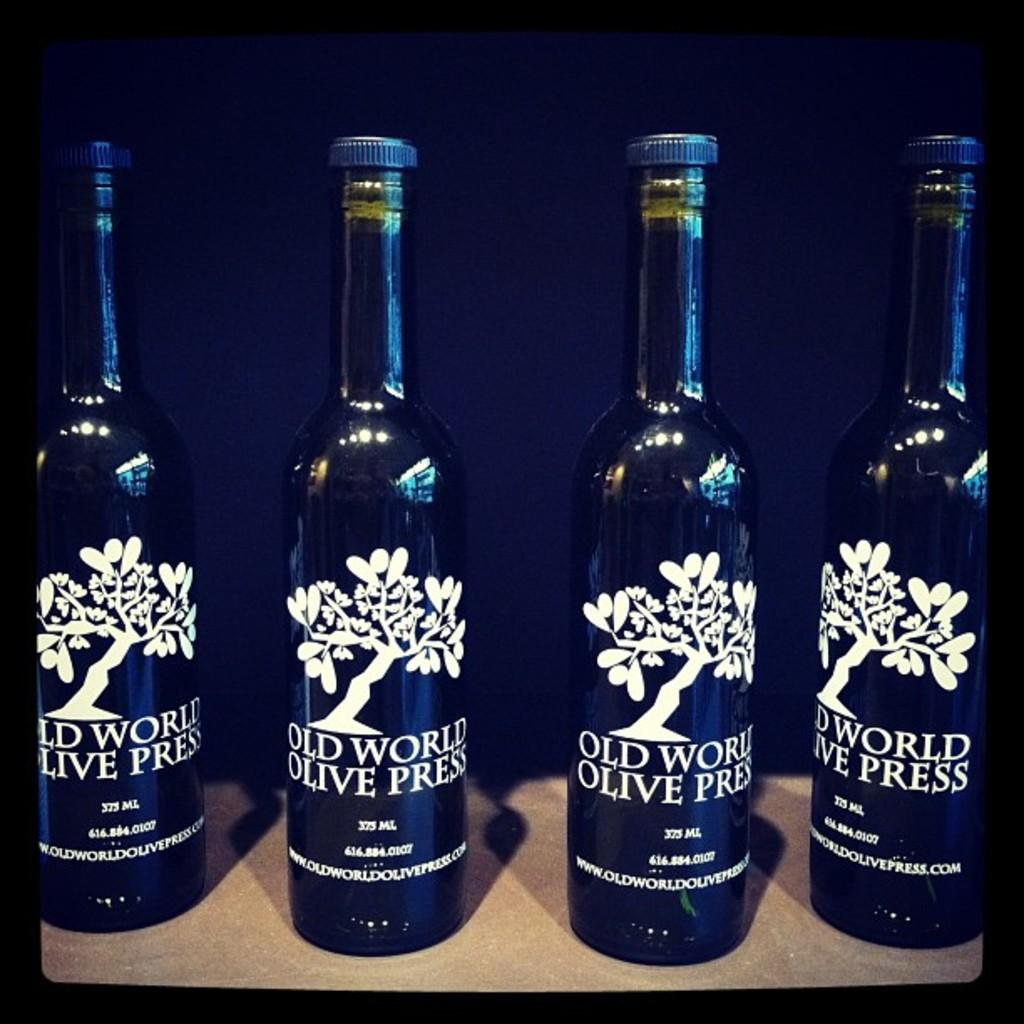<image>
Render a clear and concise summary of the photo. Four bottles of Old World Olive Press are displayed. 